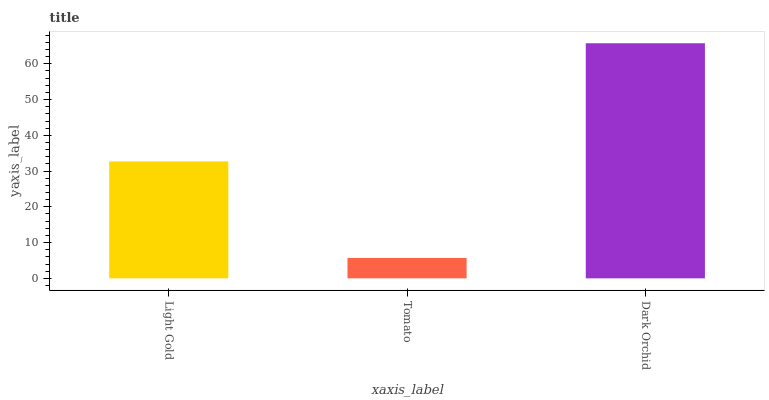Is Tomato the minimum?
Answer yes or no. Yes. Is Dark Orchid the maximum?
Answer yes or no. Yes. Is Dark Orchid the minimum?
Answer yes or no. No. Is Tomato the maximum?
Answer yes or no. No. Is Dark Orchid greater than Tomato?
Answer yes or no. Yes. Is Tomato less than Dark Orchid?
Answer yes or no. Yes. Is Tomato greater than Dark Orchid?
Answer yes or no. No. Is Dark Orchid less than Tomato?
Answer yes or no. No. Is Light Gold the high median?
Answer yes or no. Yes. Is Light Gold the low median?
Answer yes or no. Yes. Is Tomato the high median?
Answer yes or no. No. Is Dark Orchid the low median?
Answer yes or no. No. 